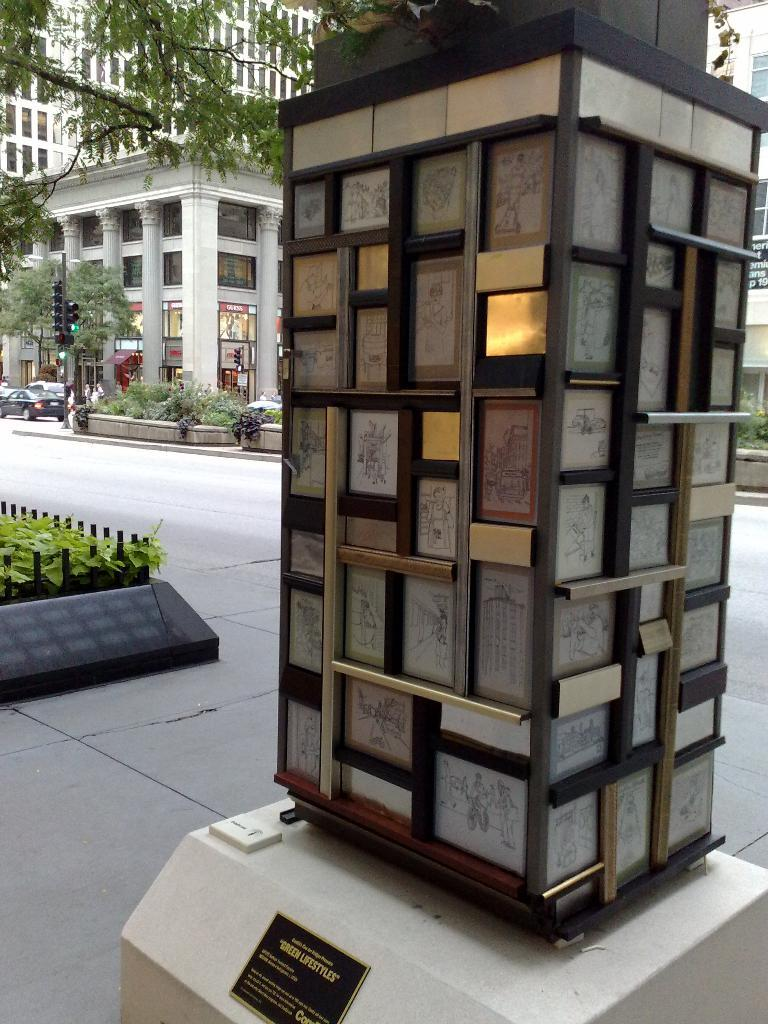What is the main structure in the image? There is a pillar in the image. What is attached to the pillar? Photo frames are attached to the pillar. What type of structures can be seen in the background? There are buildings in the image. What material is present on the buildings? Glass is present in the image, specifically on the windows. What type of vegetation is in the image? There is a tree in the image. What is the purpose of the signal pole in the image? The signal pole is present in the image to regulate traffic or provide information. What type of pathway is visible in the image? There is a road in the image. What type of transportation is visible on the road? Vehicles are visible in the image. Where is the lake located in the image? There is no lake present in the image. What type of clothing is being worn by the need in the image? There is no need present in the image, and therefore no clothing can be observed. 